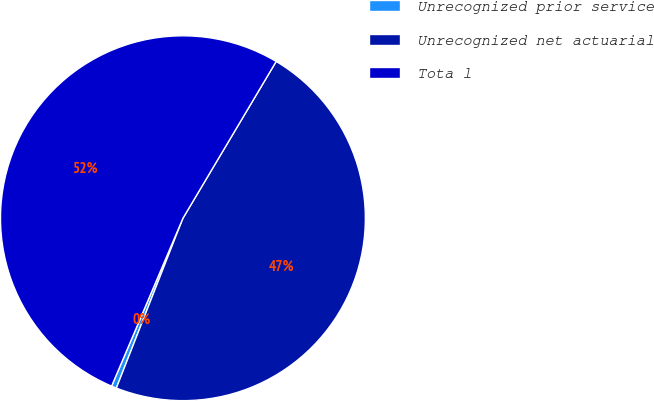Convert chart to OTSL. <chart><loc_0><loc_0><loc_500><loc_500><pie_chart><fcel>Unrecognized prior service<fcel>Unrecognized net actuarial<fcel>Tota l<nl><fcel>0.45%<fcel>47.4%<fcel>52.14%<nl></chart> 